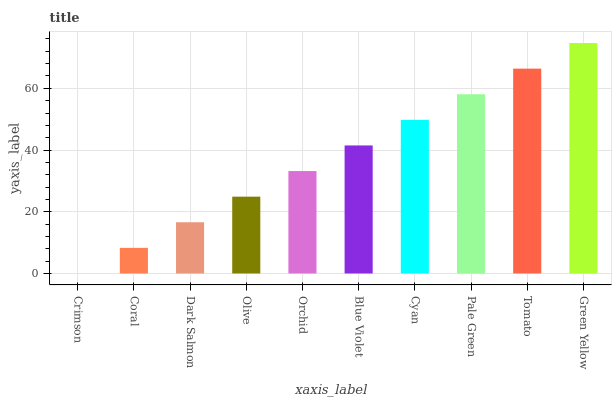Is Crimson the minimum?
Answer yes or no. Yes. Is Green Yellow the maximum?
Answer yes or no. Yes. Is Coral the minimum?
Answer yes or no. No. Is Coral the maximum?
Answer yes or no. No. Is Coral greater than Crimson?
Answer yes or no. Yes. Is Crimson less than Coral?
Answer yes or no. Yes. Is Crimson greater than Coral?
Answer yes or no. No. Is Coral less than Crimson?
Answer yes or no. No. Is Blue Violet the high median?
Answer yes or no. Yes. Is Orchid the low median?
Answer yes or no. Yes. Is Dark Salmon the high median?
Answer yes or no. No. Is Coral the low median?
Answer yes or no. No. 